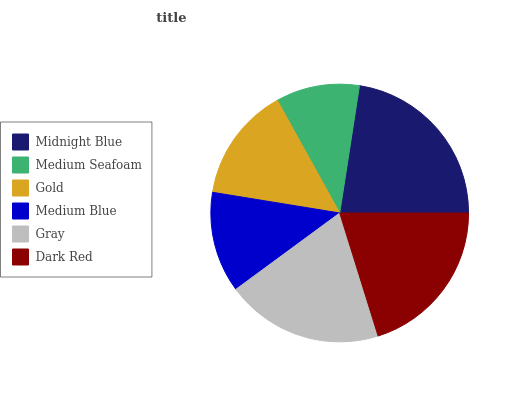Is Medium Seafoam the minimum?
Answer yes or no. Yes. Is Midnight Blue the maximum?
Answer yes or no. Yes. Is Gold the minimum?
Answer yes or no. No. Is Gold the maximum?
Answer yes or no. No. Is Gold greater than Medium Seafoam?
Answer yes or no. Yes. Is Medium Seafoam less than Gold?
Answer yes or no. Yes. Is Medium Seafoam greater than Gold?
Answer yes or no. No. Is Gold less than Medium Seafoam?
Answer yes or no. No. Is Gray the high median?
Answer yes or no. Yes. Is Gold the low median?
Answer yes or no. Yes. Is Medium Seafoam the high median?
Answer yes or no. No. Is Medium Blue the low median?
Answer yes or no. No. 